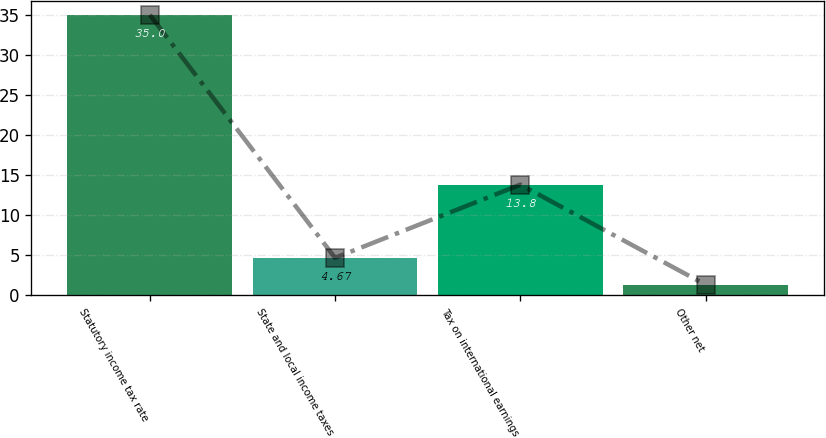Convert chart. <chart><loc_0><loc_0><loc_500><loc_500><bar_chart><fcel>Statutory income tax rate<fcel>State and local income taxes<fcel>Tax on international earnings<fcel>Other net<nl><fcel>35<fcel>4.67<fcel>13.8<fcel>1.3<nl></chart> 